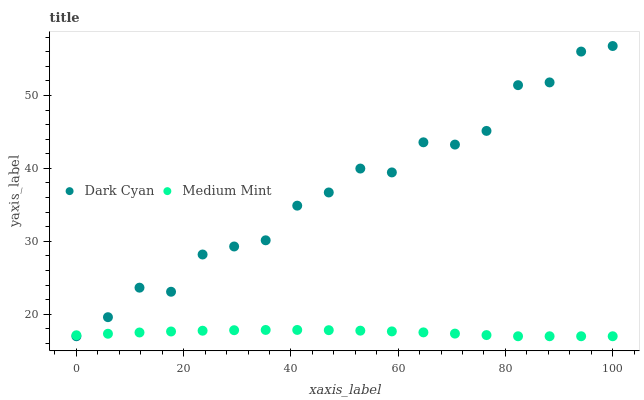Does Medium Mint have the minimum area under the curve?
Answer yes or no. Yes. Does Dark Cyan have the maximum area under the curve?
Answer yes or no. Yes. Does Medium Mint have the maximum area under the curve?
Answer yes or no. No. Is Medium Mint the smoothest?
Answer yes or no. Yes. Is Dark Cyan the roughest?
Answer yes or no. Yes. Is Medium Mint the roughest?
Answer yes or no. No. Does Dark Cyan have the lowest value?
Answer yes or no. Yes. Does Dark Cyan have the highest value?
Answer yes or no. Yes. Does Medium Mint have the highest value?
Answer yes or no. No. Does Dark Cyan intersect Medium Mint?
Answer yes or no. Yes. Is Dark Cyan less than Medium Mint?
Answer yes or no. No. Is Dark Cyan greater than Medium Mint?
Answer yes or no. No. 